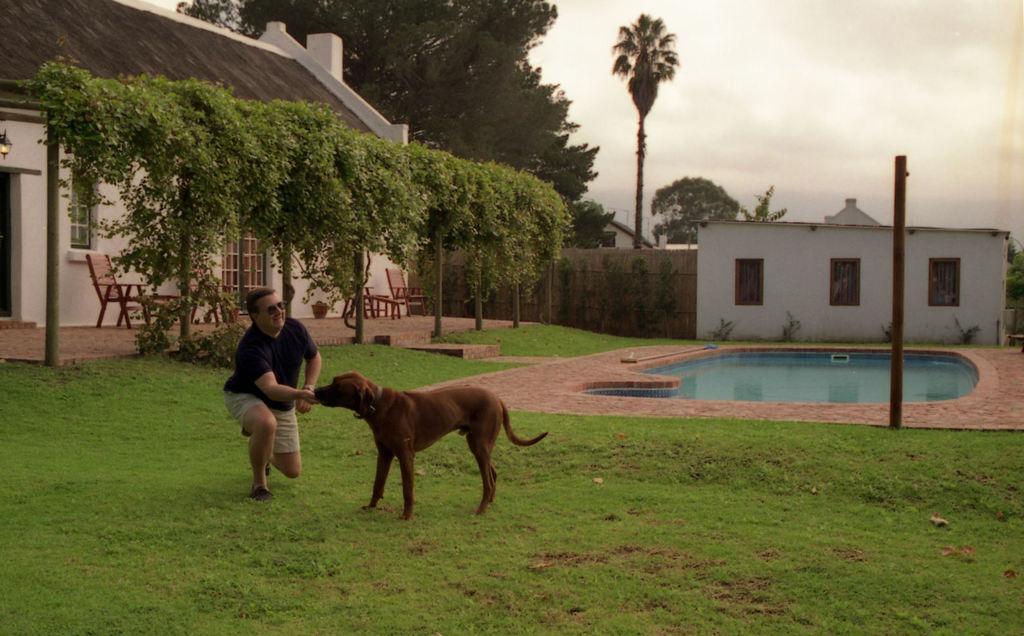How would you summarize this image in a sentence or two? In this image there is a man feeding food for the dog and at the back ground there is a house , chair , door, trees , plants ,a small pool and a sky covered with clouds. 